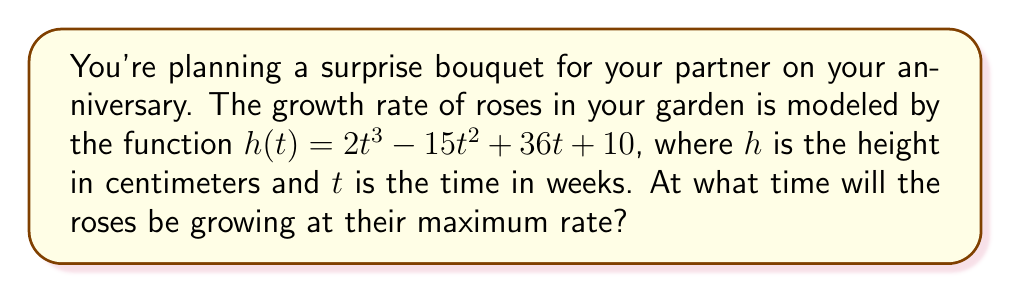Can you solve this math problem? To find when the roses are growing at their maximum rate, we need to find the maximum value of the first derivative of $h(t)$.

Step 1: Find the first derivative $h'(t)$
$$h'(t) = 6t^2 - 30t + 36$$

Step 2: Find the second derivative $h''(t)$
$$h''(t) = 12t - 30$$

Step 3: Set $h''(t) = 0$ and solve for $t$
$$12t - 30 = 0$$
$$12t = 30$$
$$t = \frac{30}{12} = \frac{5}{2} = 2.5$$

Step 4: Verify this is a maximum by checking if $h''(2.5) < 0$
$$h''(2.5) = 12(2.5) - 30 = 30 - 30 = 0$$

Since $h''(2.5) = 0$, we need to check values on either side:
$h''(2.4) < 0$ and $h''(2.6) > 0$

This confirms that $t = 2.5$ is an inflection point, and $h'(t)$ reaches its maximum at this point.

Therefore, the roses will be growing at their maximum rate after 2.5 weeks.
Answer: 2.5 weeks 